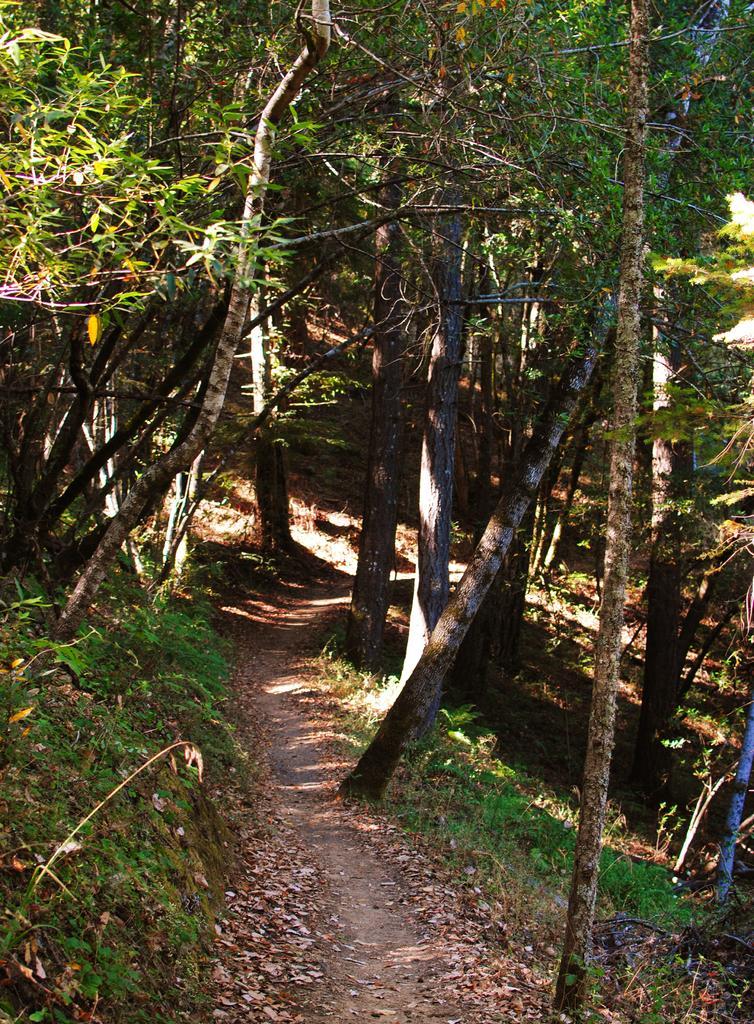Describe this image in one or two sentences. It is a forest and there are dense trees in the forest and in between the trees there is a walkway. 